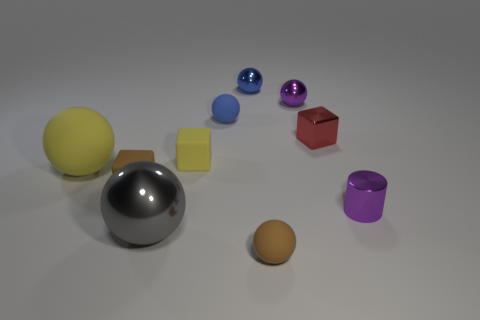Are there any other things that are the same color as the cylinder?
Your answer should be very brief. Yes. There is a gray object that is the same material as the red object; what is its size?
Offer a terse response. Large. How big is the purple object that is behind the small yellow matte block?
Your answer should be compact. Small. What number of blue matte balls are the same size as the gray metal ball?
Offer a terse response. 0. Is there a small thing of the same color as the large rubber sphere?
Offer a very short reply. Yes. What is the color of the metal cylinder that is the same size as the red shiny object?
Ensure brevity in your answer.  Purple. There is a shiny cylinder; does it have the same color as the small metallic sphere that is right of the blue metallic thing?
Offer a very short reply. Yes. What is the color of the tiny shiny cylinder?
Keep it short and to the point. Purple. There is a small ball right of the brown matte sphere; what is it made of?
Ensure brevity in your answer.  Metal. The yellow thing that is the same shape as the large gray shiny object is what size?
Offer a very short reply. Large. 